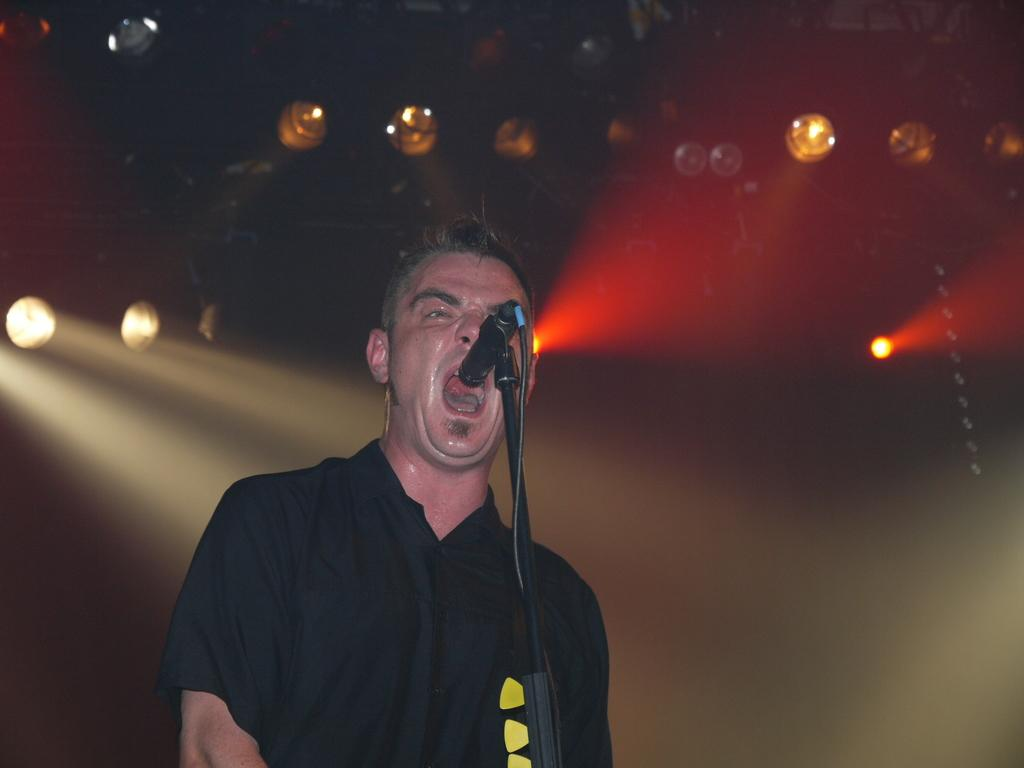What is the main subject of the image? There is a person in the image. What is the person wearing? The person is wearing a black and yellow colored dress. What is the person doing in the image? The person is standing in front of a microphone. What can be seen in the background of the image? There are lights in the background of the image, and the background is dark. What type of soap is being used to clean the train in the image? There is no train or soap present in the image. Is the person in the image wearing a winter coat? The provided facts do not mention a winter coat; the person is wearing a black and yellow colored dress. 